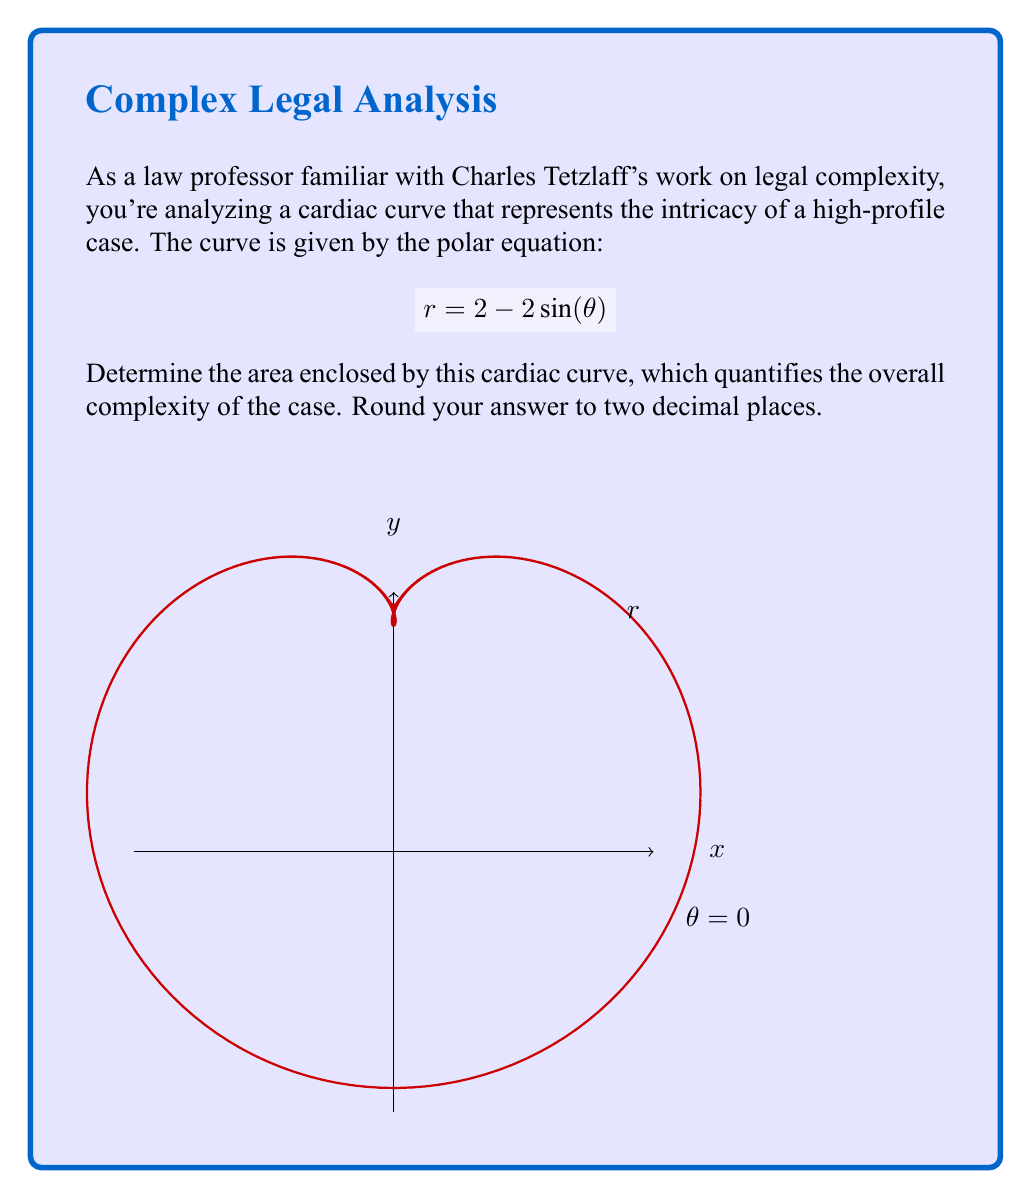Could you help me with this problem? Let's approach this step-by-step:

1) The area of a polar curve is given by the formula:

   $$A = \frac{1}{2} \int_{0}^{2\pi} r^2 d\theta$$

2) We need to substitute our given equation $r = 2 - 2\sin(\theta)$ into this formula:

   $$A = \frac{1}{2} \int_{0}^{2\pi} (2 - 2\sin(\theta))^2 d\theta$$

3) Expand the squared term:

   $$A = \frac{1}{2} \int_{0}^{2\pi} (4 - 8\sin(\theta) + 4\sin^2(\theta)) d\theta$$

4) Distribute the $\frac{1}{2}$:

   $$A = \int_{0}^{2\pi} (2 - 4\sin(\theta) + 2\sin^2(\theta)) d\theta$$

5) Now, we can integrate each term separately:

   $$A = [2\theta - 4\cos(\theta) + \theta - \frac{1}{2}\sin(2\theta)]_{0}^{2\pi}$$

6) Evaluate the integral:

   $$A = [(2\pi - 4\cos(2\pi) + \pi - \frac{1}{2}\sin(4\pi)) - (0 - 4\cos(0) + 0 - \frac{1}{2}\sin(0))]$$

7) Simplify, noting that $\cos(2\pi) = 1$ and $\sin(4\pi) = 0$:

   $$A = [3\pi - 4 + 4] = 3\pi$$

8) The final step is to round to two decimal places:

   $$A \approx 9.42$$
Answer: $9.42$ 